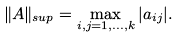<formula> <loc_0><loc_0><loc_500><loc_500>\| A \| _ { s u p } = \max _ { i , j = 1 , \dots , k } | a _ { i j } | .</formula> 